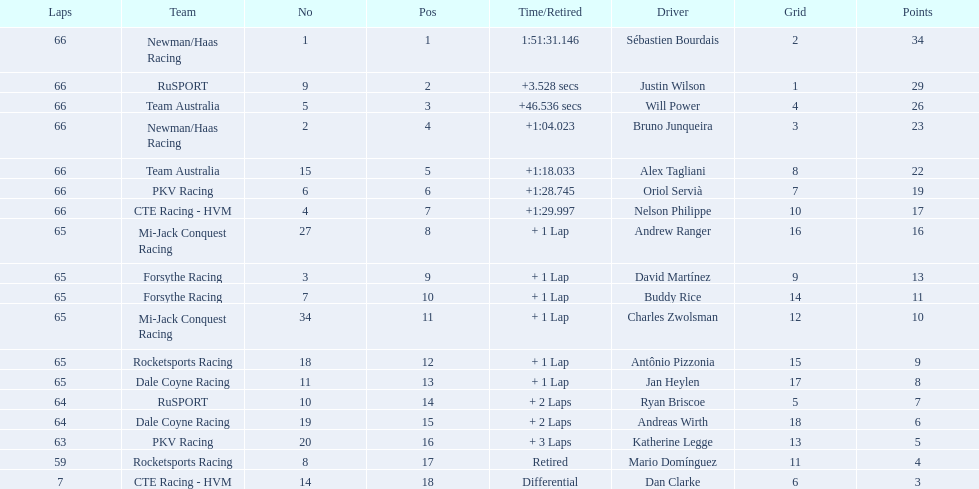How many points did first place receive? 34. How many did last place receive? 3. Who was the recipient of these last place points? Dan Clarke. 